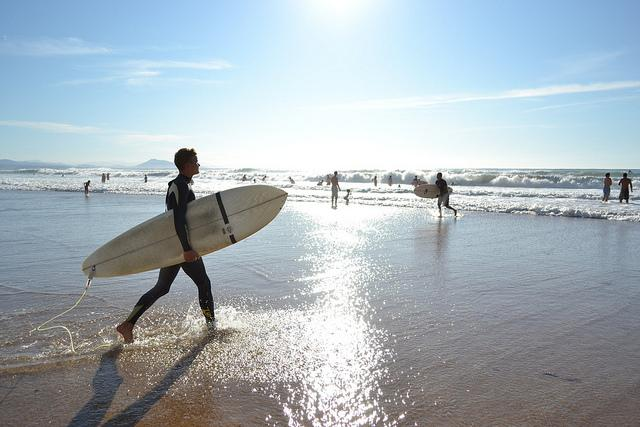What is the man walking to? ocean 